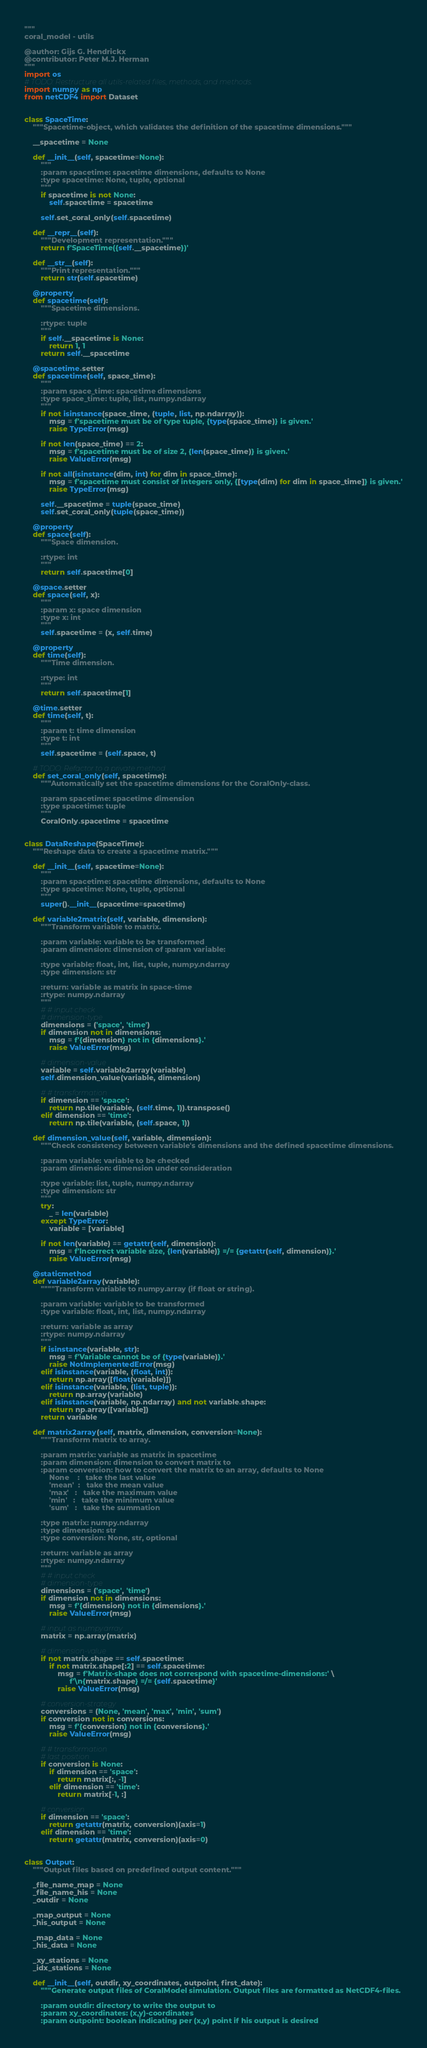Convert code to text. <code><loc_0><loc_0><loc_500><loc_500><_Python_>"""
coral_model - utils

@author: Gijs G. Hendrickx
@contributor: Peter M.J. Herman
"""
import os
# TODO: Restructure all utils-related files, methods, and methods.
import numpy as np
from netCDF4 import Dataset


class SpaceTime:
    """Spacetime-object, which validates the definition of the spacetime dimensions."""

    __spacetime = None

    def __init__(self, spacetime=None):
        """
        :param spacetime: spacetime dimensions, defaults to None
        :type spacetime: None, tuple, optional
        """
        if spacetime is not None:
            self.spacetime = spacetime
        
        self.set_coral_only(self.spacetime)

    def __repr__(self):
        """Development representation."""
        return f'SpaceTime({self.__spacetime})'

    def __str__(self):
        """Print representation."""
        return str(self.spacetime)

    @property
    def spacetime(self):
        """Spacetime dimensions.

        :rtype: tuple
        """
        if self.__spacetime is None:
            return 1, 1
        return self.__spacetime

    @spacetime.setter
    def spacetime(self, space_time):
        """
        :param space_time: spacetime dimensions
        :type space_time: tuple, list, numpy.ndarray
        """
        if not isinstance(space_time, (tuple, list, np.ndarray)):
            msg = f'spacetime must be of type tuple, {type(space_time)} is given.'
            raise TypeError(msg)

        if not len(space_time) == 2:
            msg = f'spacetime must be of size 2, {len(space_time)} is given.'
            raise ValueError(msg)

        if not all(isinstance(dim, int) for dim in space_time):
            msg = f'spacetime must consist of integers only, {[type(dim) for dim in space_time]} is given.'
            raise TypeError(msg)

        self.__spacetime = tuple(space_time)
        self.set_coral_only(tuple(space_time))

    @property
    def space(self):
        """Space dimension.

        :rtype: int
        """
        return self.spacetime[0]

    @space.setter
    def space(self, x):
        """
        :param x: space dimension
        :type x: int
        """
        self.spacetime = (x, self.time)

    @property
    def time(self):
        """Time dimension.

        :rtype: int
        """
        return self.spacetime[1]

    @time.setter
    def time(self, t):
        """
        :param t: time dimension
        :type t: int
        """
        self.spacetime = (self.space, t)
        
    # TODO: Refactor to a private method
    def set_coral_only(self, spacetime):
        """Automatically set the spacetime dimensions for the CoralOnly-class.
        
        :param spacetime: spacetime dimension
        :type spacetime: tuple
        """
        CoralOnly.spacetime = spacetime
        

class DataReshape(SpaceTime):
    """Reshape data to create a spacetime matrix."""

    def __init__(self, spacetime=None):
        """
        :param spacetime: spacetime dimensions, defaults to None
        :type spacetime: None, tuple, optional
        """
        super().__init__(spacetime=spacetime)
    
    def variable2matrix(self, variable, dimension):
        """Transform variable to matrix.
        
        :param variable: variable to be transformed
        :param dimension: dimension of :param variable:
            
        :type variable: float, int, list, tuple, numpy.ndarray
        :type dimension: str

        :return: variable as matrix in space-time
        :rtype: numpy.ndarray
        """
        # # input check
        # dimension-type
        dimensions = ('space', 'time')
        if dimension not in dimensions:
            msg = f'{dimension} not in {dimensions}.'
            raise ValueError(msg)

        # dimension-value
        variable = self.variable2array(variable)
        self.dimension_value(variable, dimension)

        # # transformation
        if dimension == 'space':
            return np.tile(variable, (self.time, 1)).transpose()
        elif dimension == 'time':
            return np.tile(variable, (self.space, 1))

    def dimension_value(self, variable, dimension):
        """Check consistency between variable's dimensions and the defined spacetime dimensions.

        :param variable: variable to be checked
        :param dimension: dimension under consideration

        :type variable: list, tuple, numpy.ndarray
        :type dimension: str
        """
        try:
            _ = len(variable)
        except TypeError:
            variable = [variable]

        if not len(variable) == getattr(self, dimension):
            msg = f'Incorrect variable size, {len(variable)} =/= {getattr(self, dimension)}.'
            raise ValueError(msg)

    @staticmethod
    def variable2array(variable):
        """"Transform variable to numpy.array (if float or string).
        
        :param variable: variable to be transformed
        :type variable: float, int, list, numpy.ndarray

        :return: variable as array
        :rtype: numpy.ndarray
        """
        if isinstance(variable, str):
            msg = f'Variable cannot be of {type(variable)}.'
            raise NotImplementedError(msg)
        elif isinstance(variable, (float, int)):
            return np.array([float(variable)])
        elif isinstance(variable, (list, tuple)):
            return np.array(variable)
        elif isinstance(variable, np.ndarray) and not variable.shape:
            return np.array([variable])
        return variable

    def matrix2array(self, matrix, dimension, conversion=None):
        """Transform matrix to array.

        :param matrix: variable as matrix in spacetime
        :param dimension: dimension to convert matrix to
        :param conversion: how to convert the matrix to an array, defaults to None
            None    :   take the last value
            'mean'  :   take the mean value
            'max'   :   take the maximum value
            'min'   :   take the minimum value
            'sum'   :   take the summation

        :type matrix: numpy.ndarray
        :type dimension: str
        :type conversion: None, str, optional

        :return: variable as array
        :rtype: numpy.ndarray
        """
        # # input check
        # dimension-type
        dimensions = ('space', 'time')
        if dimension not in dimensions:
            msg = f'{dimension} not in {dimensions}.'
            raise ValueError(msg)

        # input as numpy.array
        matrix = np.array(matrix)

        # dimension-value
        if not matrix.shape == self.spacetime:
            if not matrix.shape[:2] == self.spacetime:
                msg = f'Matrix-shape does not correspond with spacetime-dimensions:' \
                      f'\n{matrix.shape} =/= {self.spacetime}'
                raise ValueError(msg)

        # conversion-strategy
        conversions = (None, 'mean', 'max', 'min', 'sum')
        if conversion not in conversions:
            msg = f'{conversion} not in {conversions}.'
            raise ValueError(msg)

        # # transformation
        # last position
        if conversion is None:
            if dimension == 'space':
                return matrix[:, -1]
            elif dimension == 'time':
                return matrix[-1, :]

        # conversion
        if dimension == 'space':
            return getattr(matrix, conversion)(axis=1)
        elif dimension == 'time':
            return getattr(matrix, conversion)(axis=0)


class Output:
    """Output files based on predefined output content."""

    _file_name_map = None
    _file_name_his = None
    _outdir = None
    
    _map_output = None
    _his_output = None

    _map_data = None
    _his_data = None

    _xy_stations = None
    _idx_stations = None

    def __init__(self, outdir, xy_coordinates, outpoint, first_date):
        """Generate output files of CoralModel simulation. Output files are formatted as NetCDF4-files.

        :param outdir: directory to write the output to        
        :param xy_coordinates: (x,y)-coordinates
        :param outpoint: boolean indicating per (x,y) point if his output is desired</code> 